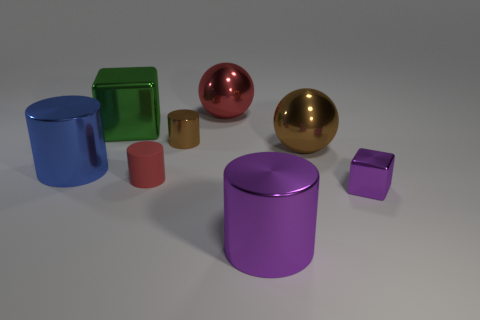Is there anything else that has the same material as the tiny red cylinder?
Ensure brevity in your answer.  No. Do the purple cylinder and the red cylinder have the same material?
Give a very brief answer. No. How many cylinders are behind the tiny red cylinder and to the right of the green cube?
Your response must be concise. 1. How many other things are there of the same color as the big block?
Provide a succinct answer. 0. What number of blue things are matte objects or balls?
Offer a terse response. 0. The brown shiny cylinder is what size?
Ensure brevity in your answer.  Small. How many metallic things are tiny red cylinders or large cubes?
Keep it short and to the point. 1. Are there fewer large purple things than tiny red metal balls?
Provide a succinct answer. No. How many other things are there of the same material as the tiny block?
Give a very brief answer. 6. The brown metal thing that is the same shape as the small rubber object is what size?
Keep it short and to the point. Small. 